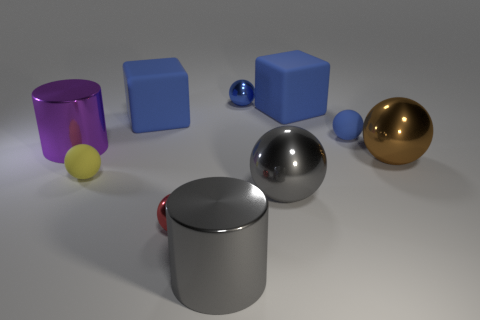How many other objects are there of the same size as the brown shiny thing?
Offer a terse response. 5. The big thing that is in front of the small blue matte ball and on the left side of the red object is made of what material?
Offer a terse response. Metal. There is a cylinder behind the red thing; does it have the same size as the gray metal cylinder?
Keep it short and to the point. Yes. What number of spheres are to the right of the tiny yellow thing and left of the big brown thing?
Ensure brevity in your answer.  4. What number of metal objects are in front of the block left of the shiny ball on the left side of the blue metallic thing?
Keep it short and to the point. 5. There is a tiny blue shiny thing; what shape is it?
Provide a short and direct response. Sphere. How many blue cubes have the same material as the tiny yellow ball?
Keep it short and to the point. 2. What color is the other large ball that is made of the same material as the big gray ball?
Offer a very short reply. Brown. Do the red shiny thing and the cylinder that is in front of the small yellow sphere have the same size?
Provide a short and direct response. No. There is a big ball that is to the right of the large rubber block that is right of the small shiny ball behind the brown metal sphere; what is it made of?
Give a very brief answer. Metal. 